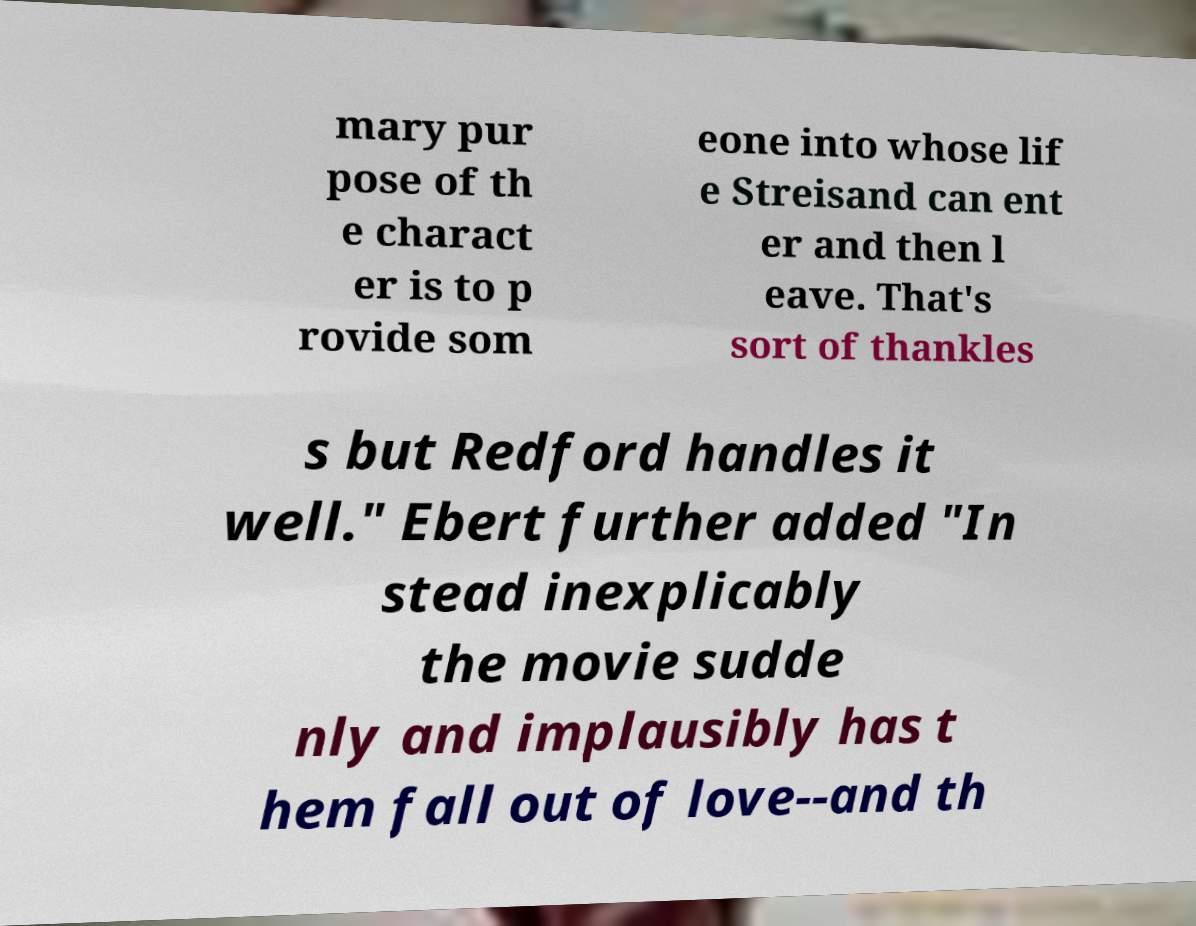Could you extract and type out the text from this image? mary pur pose of th e charact er is to p rovide som eone into whose lif e Streisand can ent er and then l eave. That's sort of thankles s but Redford handles it well." Ebert further added "In stead inexplicably the movie sudde nly and implausibly has t hem fall out of love--and th 